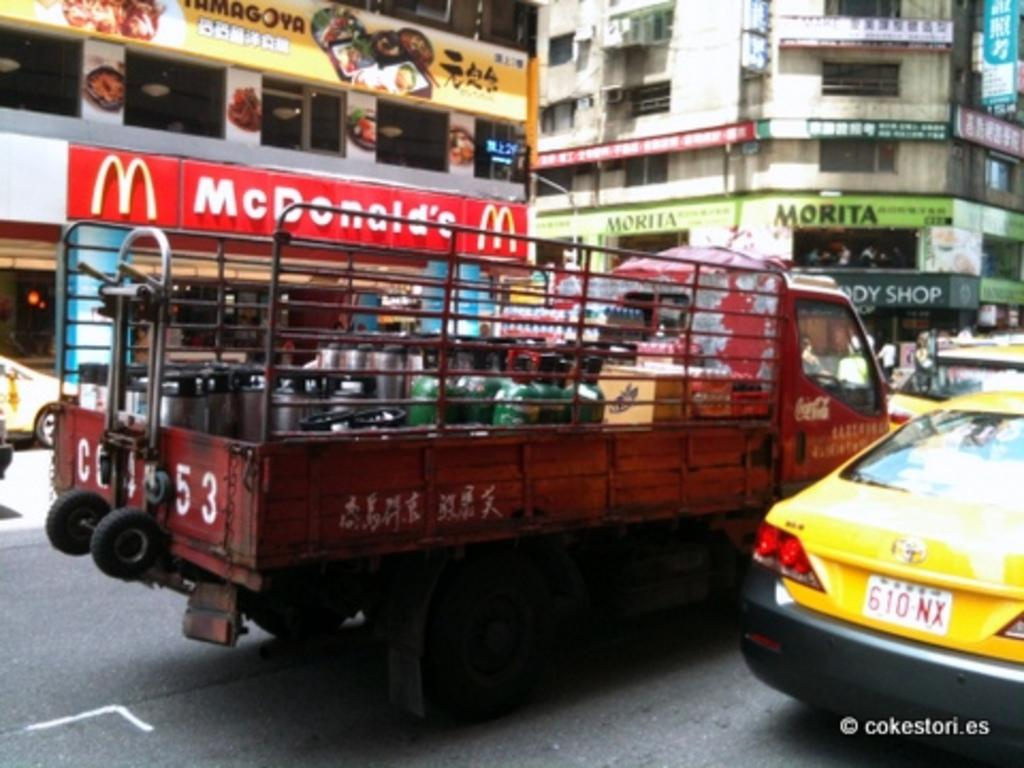Provide a one-sentence caption for the provided image. A red truck is on a busy street in front of a McDonald's. 